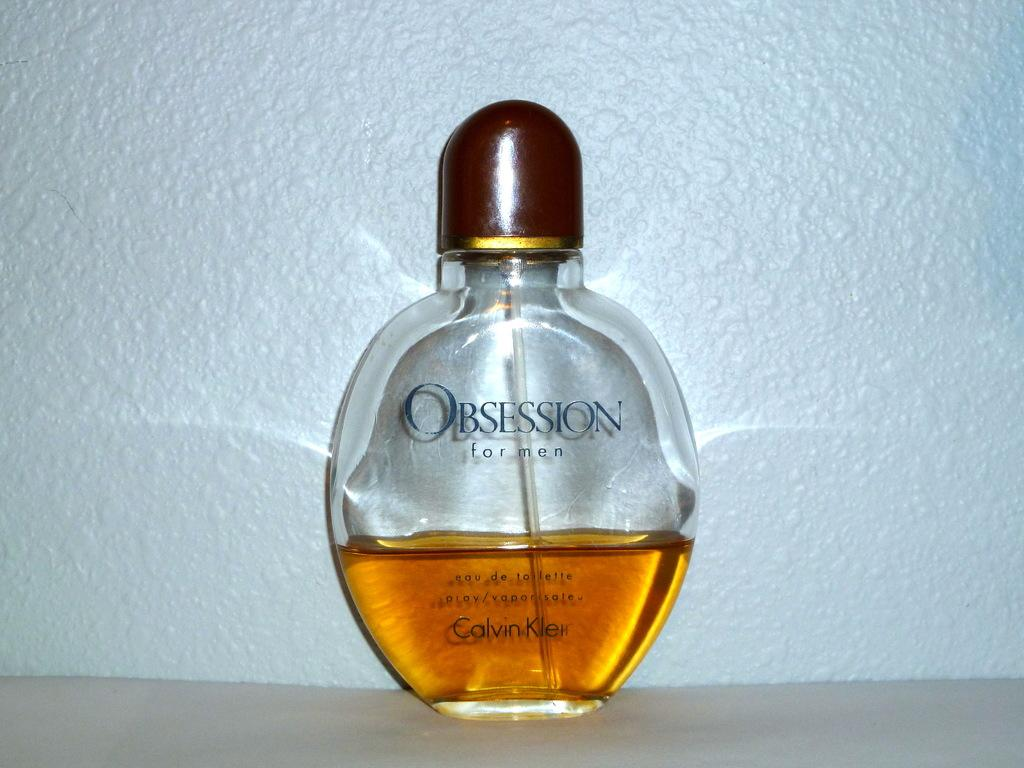<image>
Give a short and clear explanation of the subsequent image. A mostly empty bottle of Obsession by Calvin Klein. 